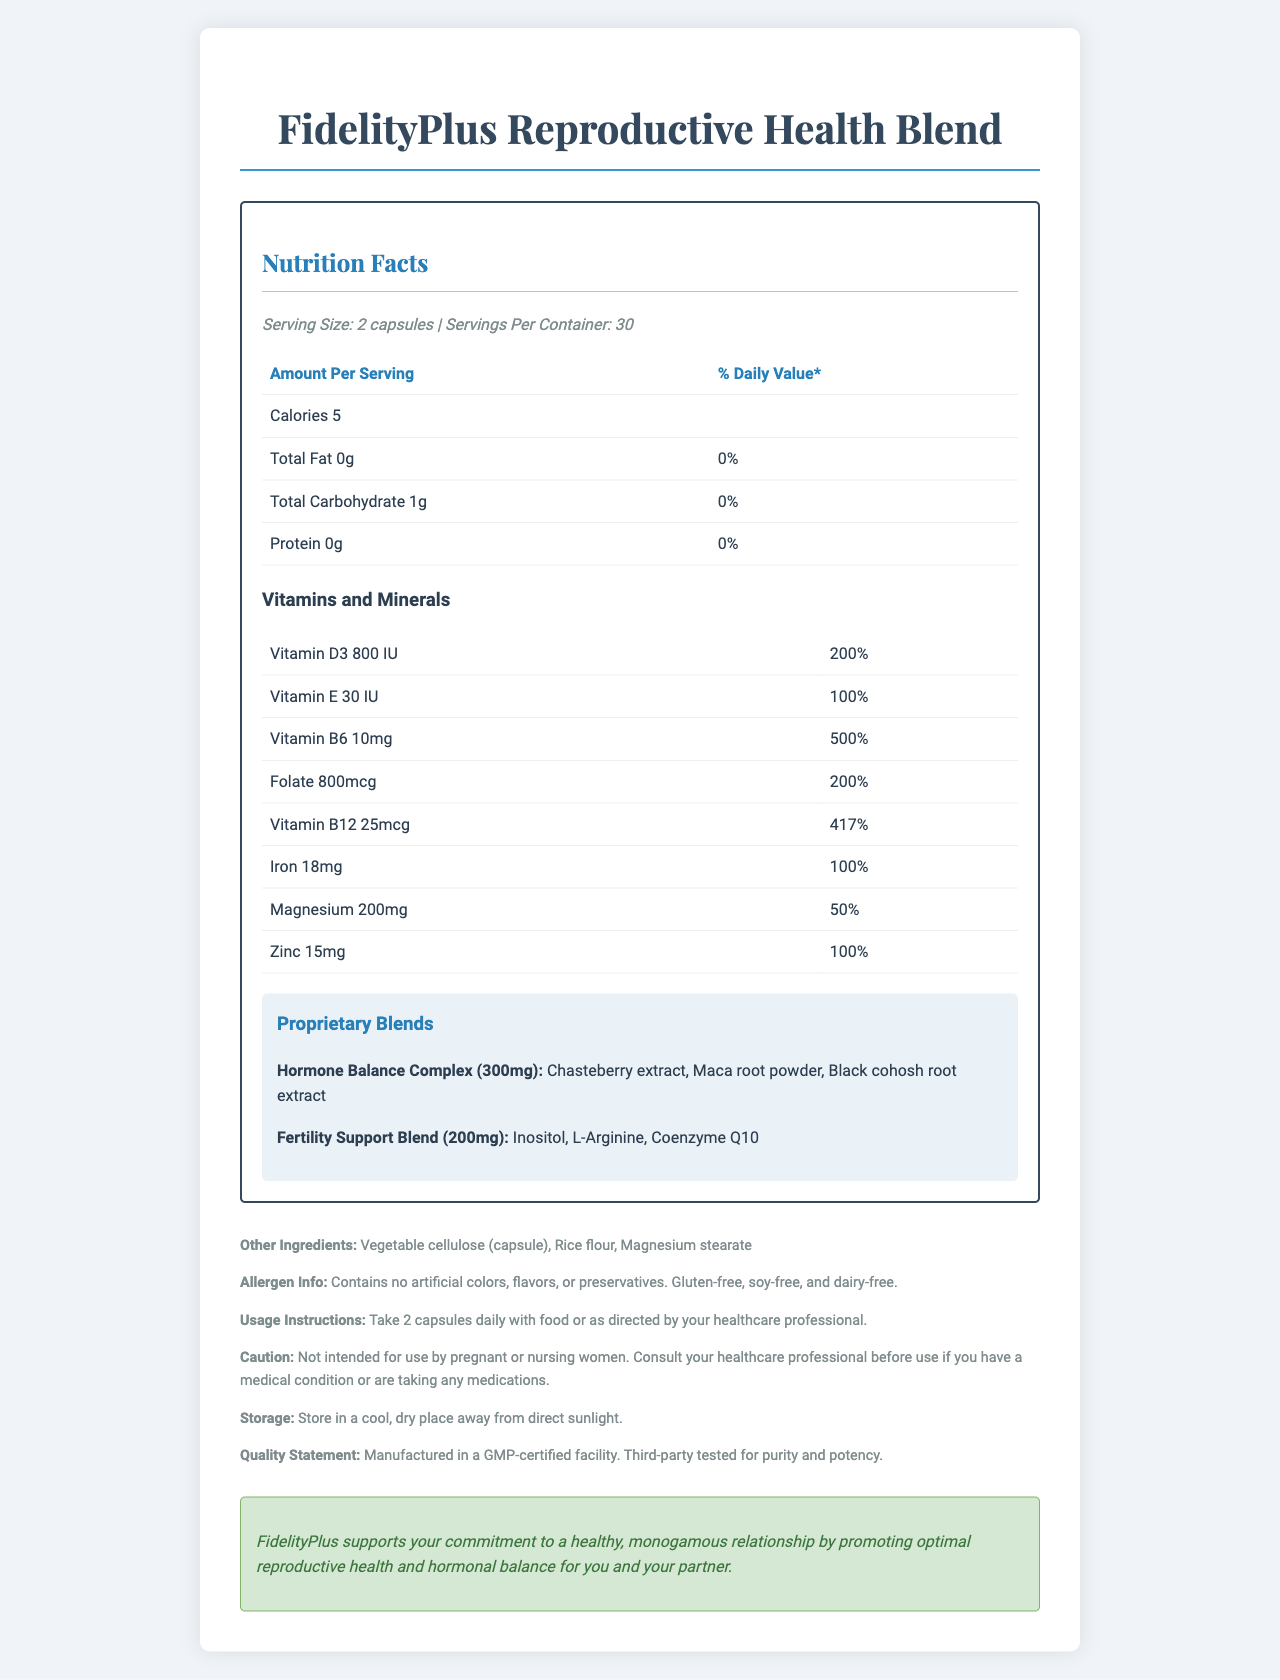what is the serving size? The document states that the serving size is "2 capsules."
Answer: 2 capsules how many calories per serving? The document specifies that each serving contains 5 calories.
Answer: 5 calories which vitamin has the highest daily value percentage? According to the document, Vitamin B6 has a daily value percentage of 500%, which is the highest among the listed vitamins and minerals.
Answer: Vitamin B6 what is the amount of folate per serving? The document lists the amount of folate per serving as 800mcg.
Answer: 800mcg which proprietary blend includes Coenzyme Q10? The document mentions that Coenzyme Q10 is an ingredient in the Fertility Support Blend.
Answer: Fertility Support Blend how often should the capsules be taken? The usage instructions specify taking 2 capsules daily.
Answer: Daily Does this product contain gluten? (yes/no) The allergen information states that the product is gluten-free.
Answer: No what is the storage recommendation for this supplement? The document provides this storage instruction.
Answer: Store in a cool, dry place away from direct sunlight which of the following is NOT an ingredient in the Hormone Balance Complex?
A. Chasteberry extract  
B. Maca root powder  
C. L-Arginine  
D. Black cohosh root extract L-Arginine is part of the Fertility Support Blend, not the Hormone Balance Complex.
Answer: C what is the primary purpose of FidelityPlus as inferred from the fidelity message?  
A. Enhance general health  
B. Support a healthy, monogamous relationship  
C. Improve digestion  
D. Boost energy levels The fidelity message states that FidelityPlus supports the commitment to a healthy, monogamous relationship by promoting optimal reproductive health and hormonal balance.
Answer: B how many servings are in one container? The document mentions there are 30 servings per container.
Answer: 30 servings list three vitamins included in this supplement and their daily values. The document lists these daily values for the respective vitamins.
Answer: Vitamin D3 (200%), Vitamin B6 (500%), Zinc (100%) is this supplement intended for pregnant or nursing women? (Yes/No) The caution section specifies that the product is not intended for use by pregnant or nursing women.
Answer: No summarize the main idea of this document. This summary captures the key points and purpose of the document, offering an overview of its contents.
Answer: The document provides detailed information about the FidelityPlus Reproductive Health Blend, a vitamin supplement designed to support reproductive health and hormonal balance. It includes nutritional details such as serving size, vitamins, and proprietary blends, as well as usage instructions, allergen information, and a fidelity message emphasizing commitment to a monogamous relationship. what is the price of the FidelityPlus Reproductive Health Blend? The document does not provide any information regarding the price of the product.
Answer: Cannot be determined 